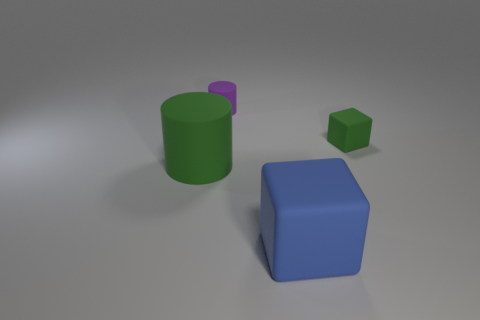There is a large rubber cylinder; are there any objects on the right side of it?
Your response must be concise. Yes. What color is the tiny rubber object left of the tiny rubber thing that is in front of the object that is behind the green rubber block?
Offer a very short reply. Purple. There is another matte thing that is the same size as the purple matte thing; what shape is it?
Offer a terse response. Cube. Are there more purple objects than blocks?
Make the answer very short. No. Is there a small object that is in front of the green object on the right side of the large block?
Offer a very short reply. No. What is the color of the large matte thing that is the same shape as the small purple rubber thing?
Ensure brevity in your answer.  Green. The big cube that is made of the same material as the tiny green object is what color?
Offer a very short reply. Blue. There is a block that is in front of the small green thing that is to the right of the purple matte cylinder; are there any large rubber objects left of it?
Offer a terse response. Yes. Is the number of big green things that are behind the small green matte thing less than the number of blocks to the left of the big block?
Your answer should be compact. No. What number of green blocks are the same material as the purple cylinder?
Give a very brief answer. 1. 